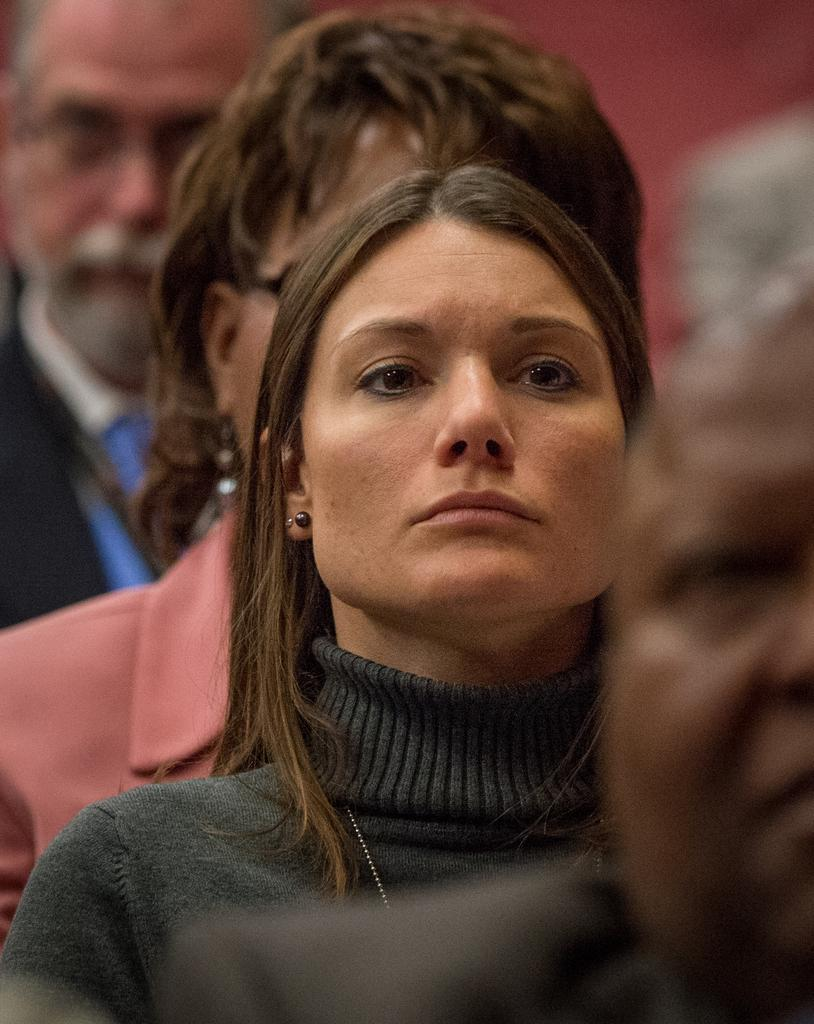Who is the main subject in the image? There is a woman in the image. What is the woman wearing? The woman is wearing a t-shirt. Are there any other people in the image? Yes, there are other people in the image. How are the other people positioned in relation to the woman? The other people are standing behind and in front of the woman. What type of crow is perched on the woman's shoulder in the image? There is no crow present in the image; it only features a woman and other people. 